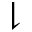<formula> <loc_0><loc_0><loc_500><loc_500>\downharpoonright</formula> 